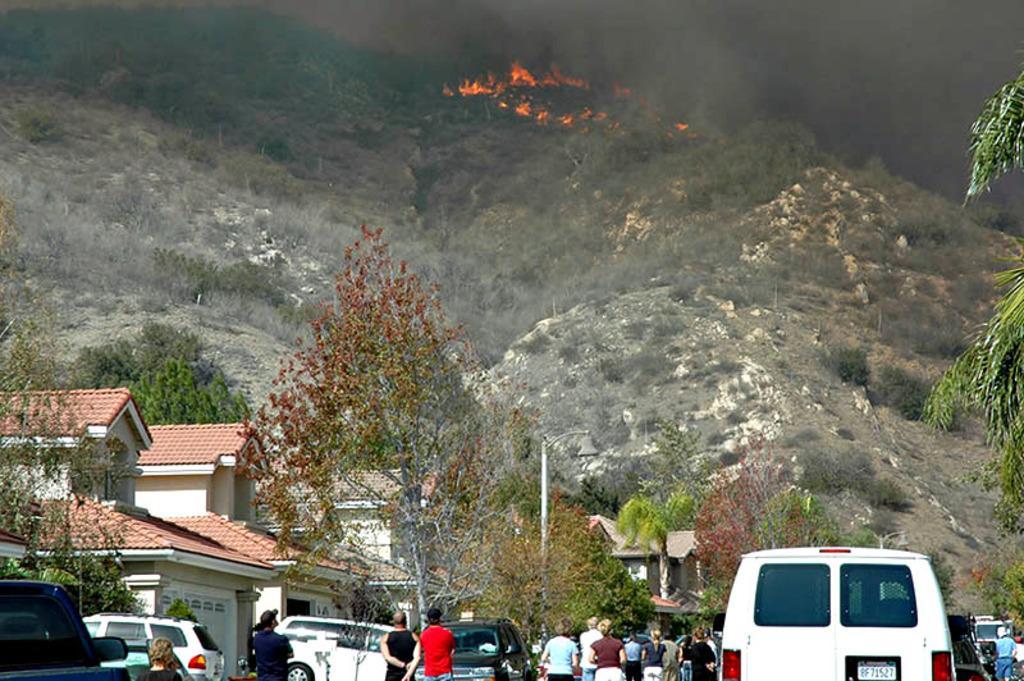Can you describe this image briefly? An outdoor picture. Far fire is on mountain. Number of trees are far away from each other. Vehicles are on road. Buildings with red roof top and white wall. People standing on road are observing the fire. 